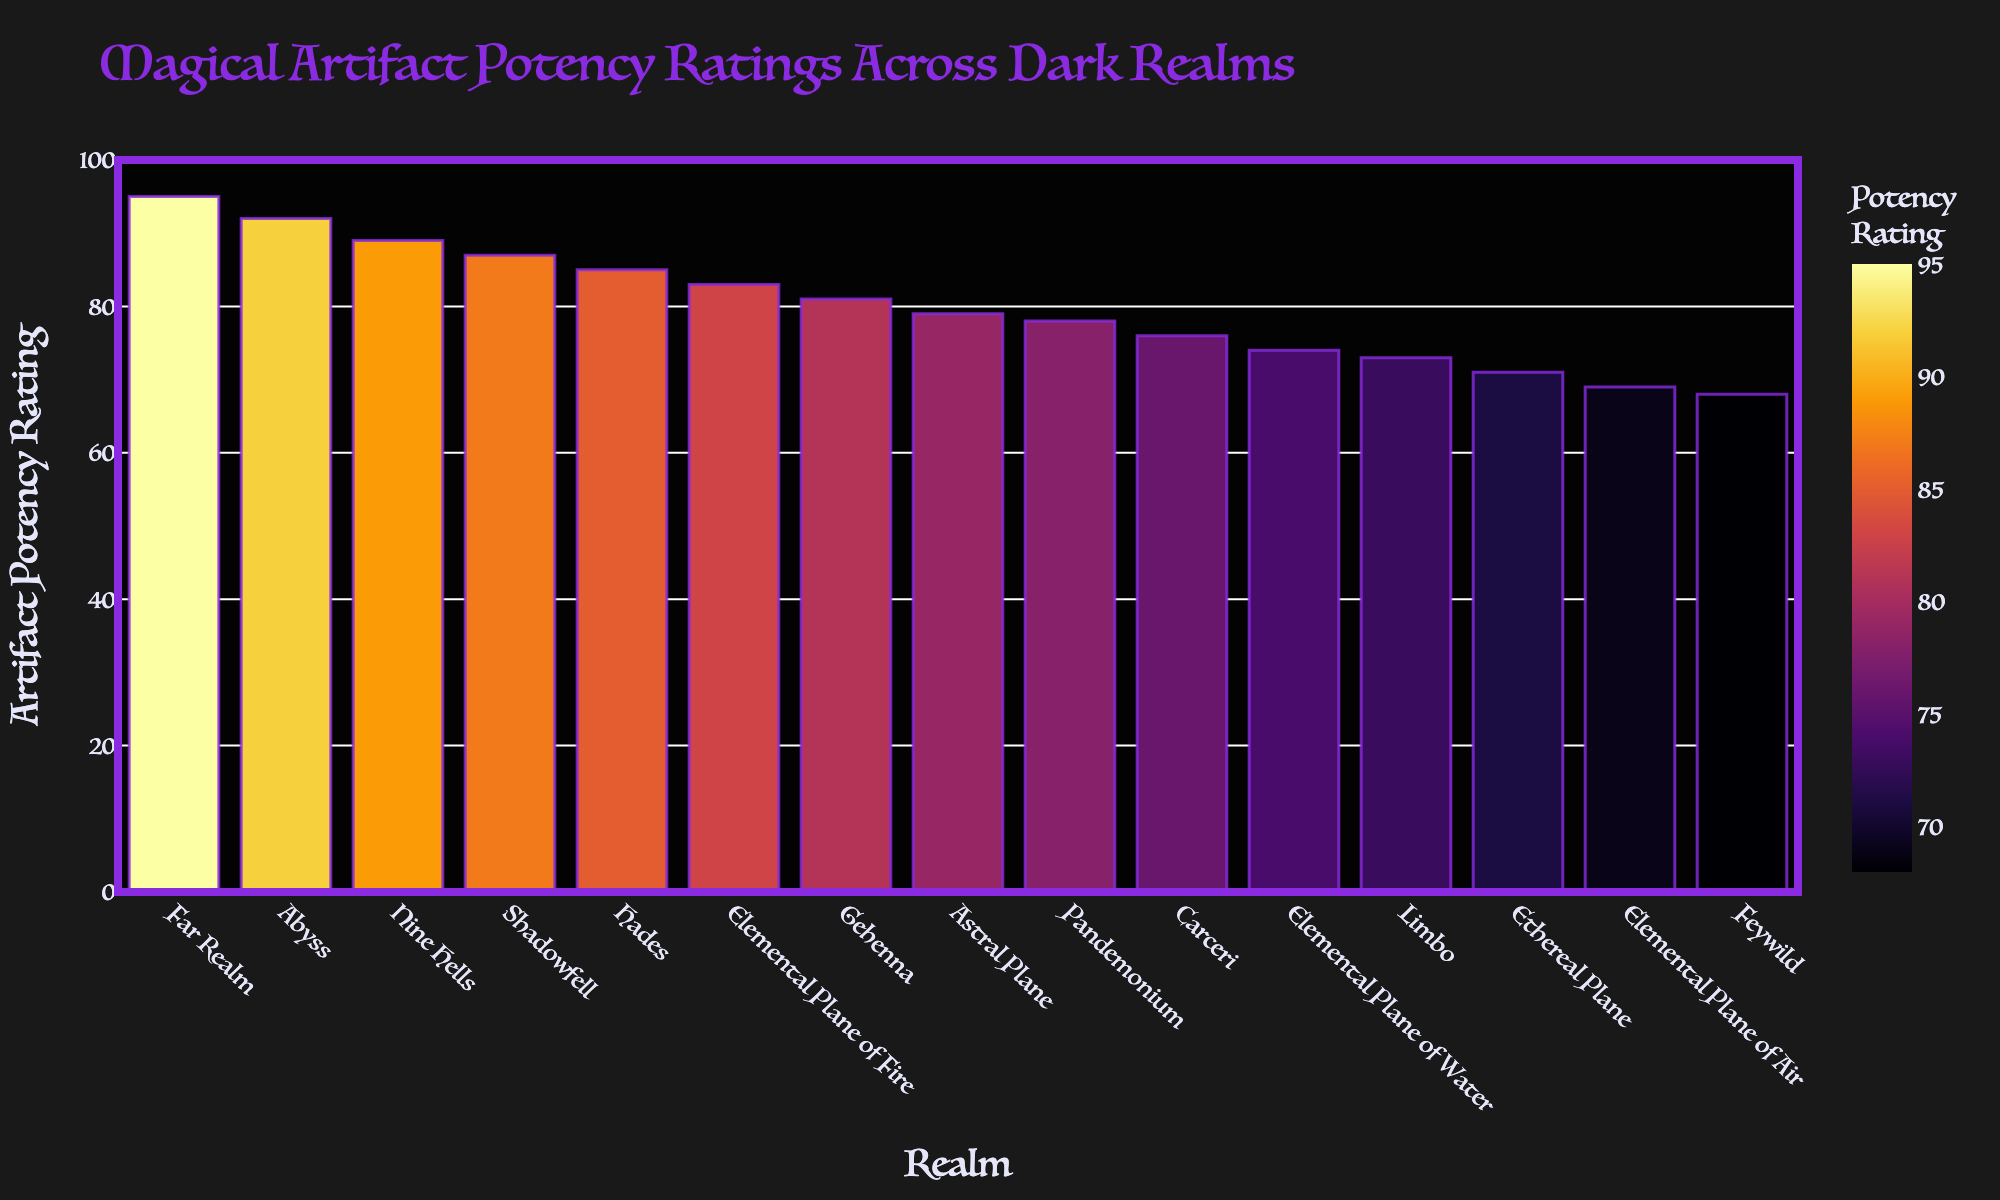Which realm has the highest Artifact Potency Rating? By looking at the height of the bars, the Far Realm has the tallest bar, indicating the highest Artifact Potency Rating.
Answer: Far Realm Which realm has the lowest Artifact Potency Rating? By examining the bars, the Feywild has the shortest bar, indicating the lowest Artifact Potency Rating.
Answer: Feywild How much higher is the Artifact Potency Rating of Gehenna compared to Carceri? The bar for Gehenna is at 81, and the bar for Carceri is at 76. Subtracting these gives 81 - 76 = 5.
Answer: 5 What is the average Artifact Potency Rating across all realms? Sum all the provided potency ratings: 87 + 92 + 89 + 78 + 85 + 81 + 76 + 73 + 95 + 68 + 79 + 71 + 83 + 74 + 69 = 1220. There are 15 realms, so divide the sum by 15: 1220 / 15 ≈ 81.33.
Answer: 81.33 Which realms have an Artifact Potency Rating higher than 80? Looking at the bars higher than the reference line for 80, the realms are Shadowfell (87), Abyss (92), Nine Hells (89), Hades (85), Gehenna (81), Far Realm (95), and the Elemental Plane of Fire (83).
Answer: Shadowfell, Abyss, Nine Hells, Hades, Gehenna, Far Realm, Elemental Plane of Fire What is the difference between the Artifact Potency Ratings of the Abyss and the Ethereal Plane? The bar for the Abyss is at 92, and the bar for the Ethereal Plane is at 71. Subtracting these gives 92 - 71 = 21.
Answer: 21 How does the Artifact Potency Rating of the Astral Plane compare to the average rating? The Astral Plane has a potency rating of 79. The average rating across all realms is 81.33. Comparing these, 79 is less than 81.33.
Answer: Less What is the sum of the Artifact Potency Ratings for the Elemental Planes (Fire, Water, and Air)? The ratings for Fire, Water, and Air are 83, 74, and 69 respectively. Summing these gives 83 + 74 + 69 = 226.
Answer: 226 